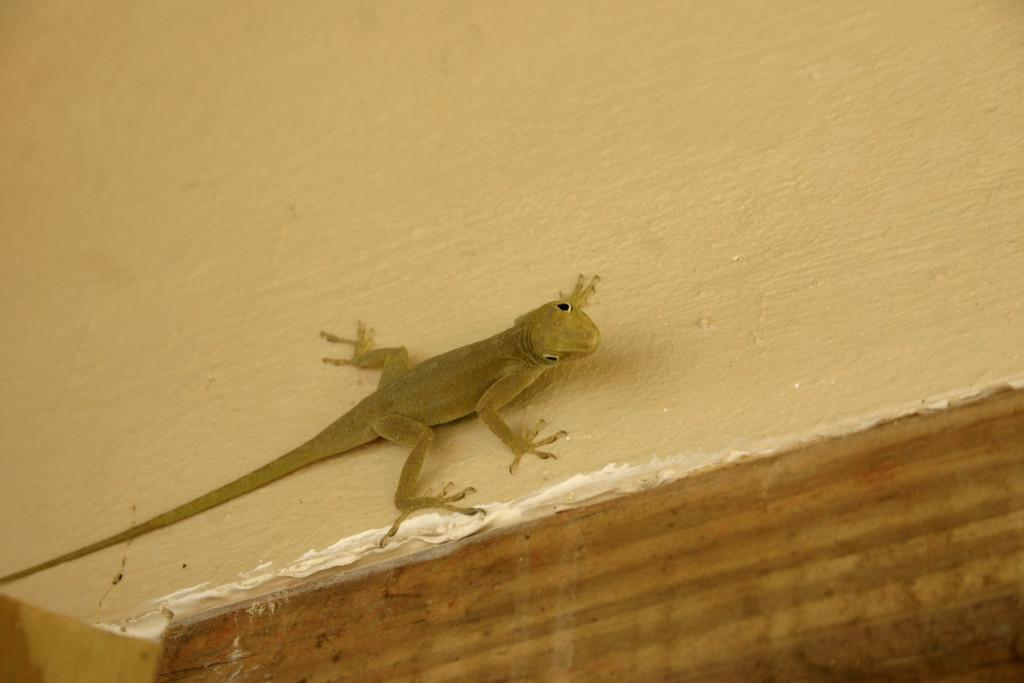What type of animal is present in the image? There is a lizard present in the image. What color is the lizard? The lizard is brown in color. What is the color of the surface the lizard is on? The surface the lizard is on is cream-colored. What type of cream is being served on the table in the image? There is no table or cream present in the image; it features a lizard on a cream-colored surface. 